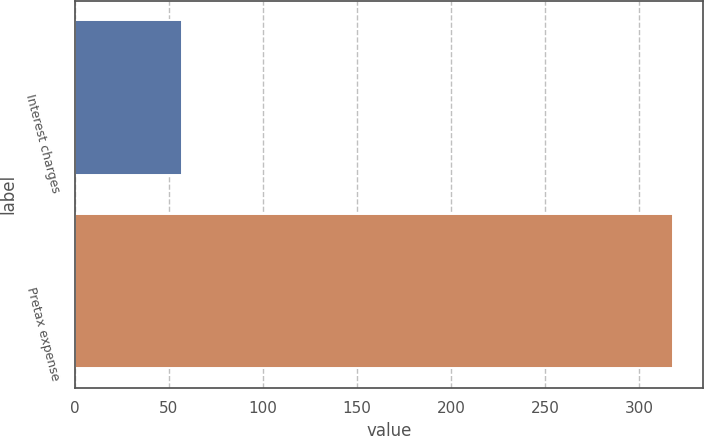Convert chart to OTSL. <chart><loc_0><loc_0><loc_500><loc_500><bar_chart><fcel>Interest charges<fcel>Pretax expense<nl><fcel>57<fcel>318<nl></chart> 